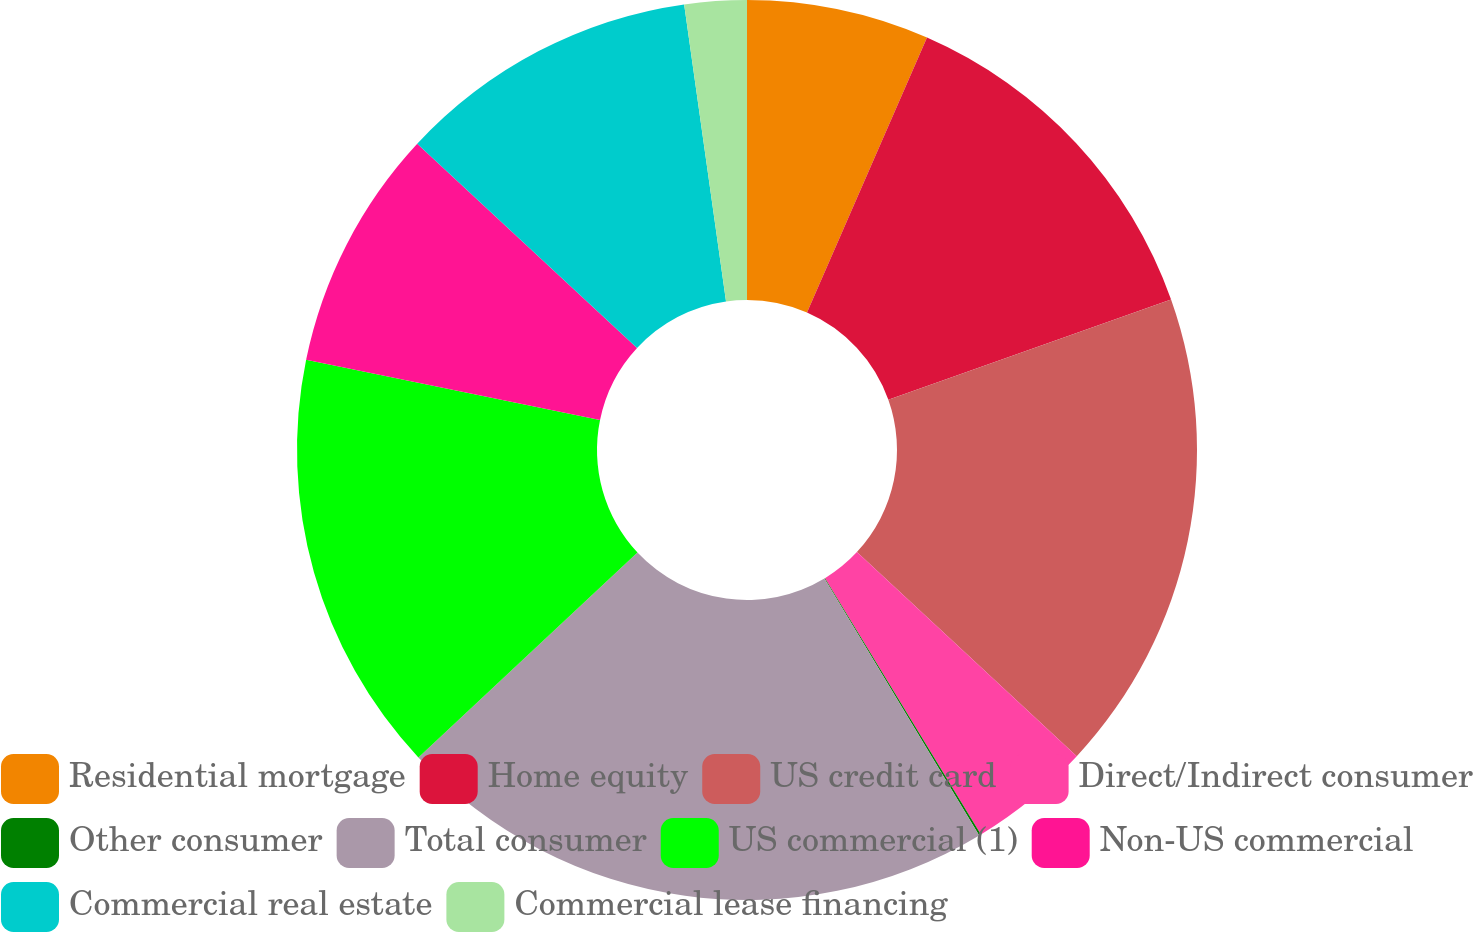Convert chart to OTSL. <chart><loc_0><loc_0><loc_500><loc_500><pie_chart><fcel>Residential mortgage<fcel>Home equity<fcel>US credit card<fcel>Direct/Indirect consumer<fcel>Other consumer<fcel>Total consumer<fcel>US commercial (1)<fcel>Non-US commercial<fcel>Commercial real estate<fcel>Commercial lease financing<nl><fcel>6.55%<fcel>13.02%<fcel>17.34%<fcel>4.39%<fcel>0.07%<fcel>21.66%<fcel>15.18%<fcel>8.7%<fcel>10.86%<fcel>2.23%<nl></chart> 